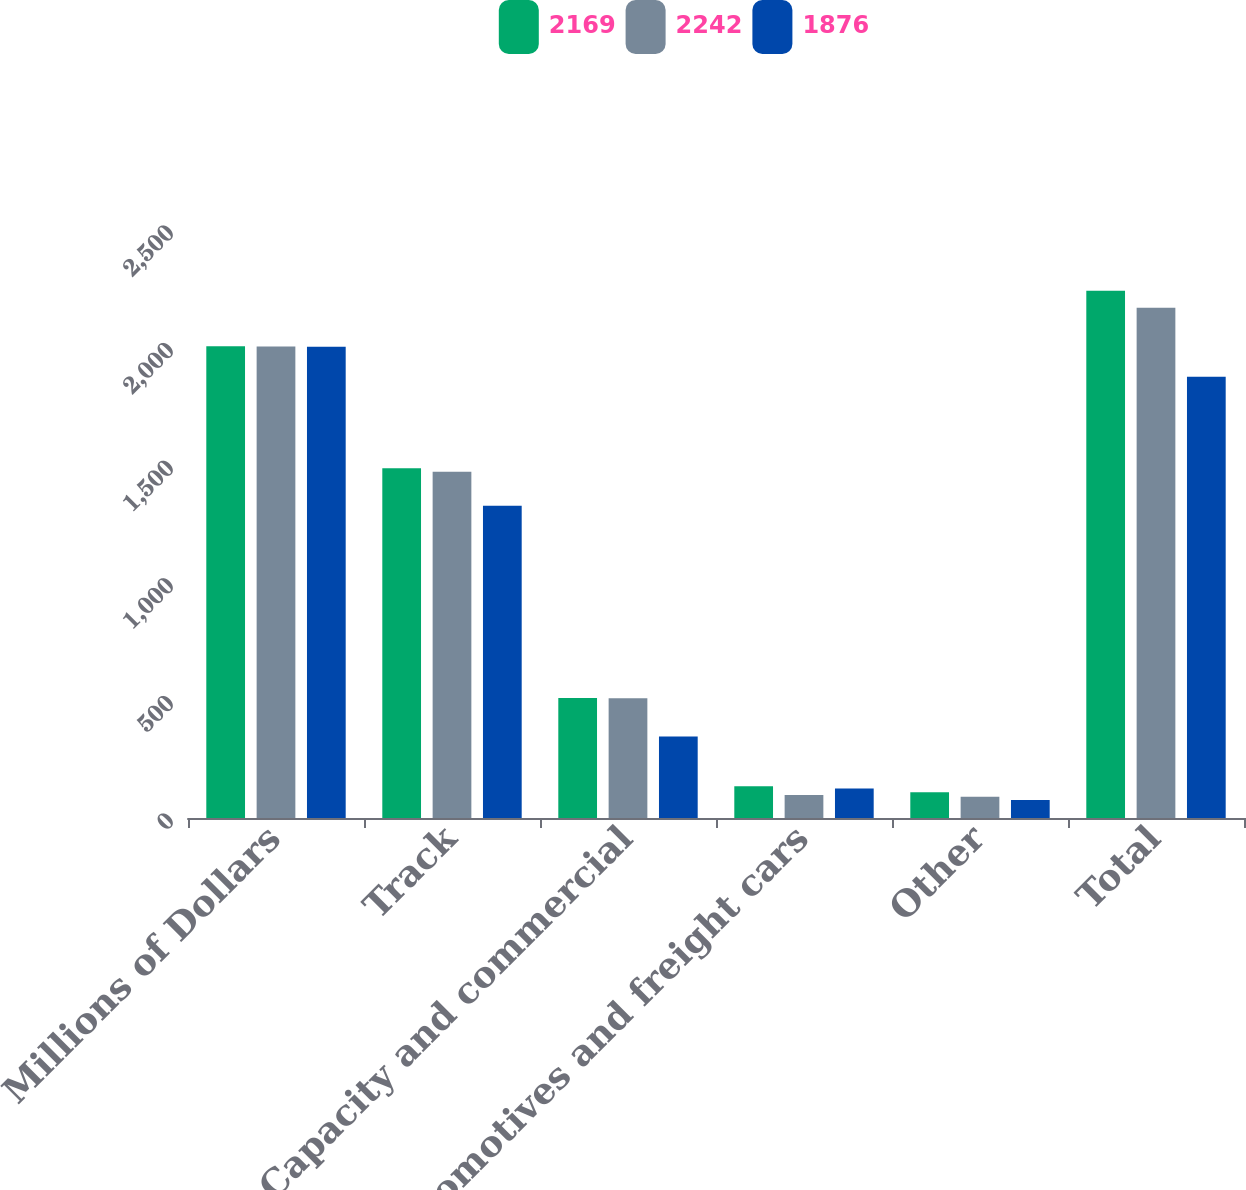<chart> <loc_0><loc_0><loc_500><loc_500><stacked_bar_chart><ecel><fcel>Millions of Dollars<fcel>Track<fcel>Capacity and commercial<fcel>Locomotives and freight cars<fcel>Other<fcel>Total<nl><fcel>2169<fcel>2006<fcel>1487<fcel>510<fcel>135<fcel>110<fcel>2242<nl><fcel>2242<fcel>2005<fcel>1472<fcel>509<fcel>98<fcel>90<fcel>2169<nl><fcel>1876<fcel>2004<fcel>1328<fcel>347<fcel>125<fcel>76<fcel>1876<nl></chart> 